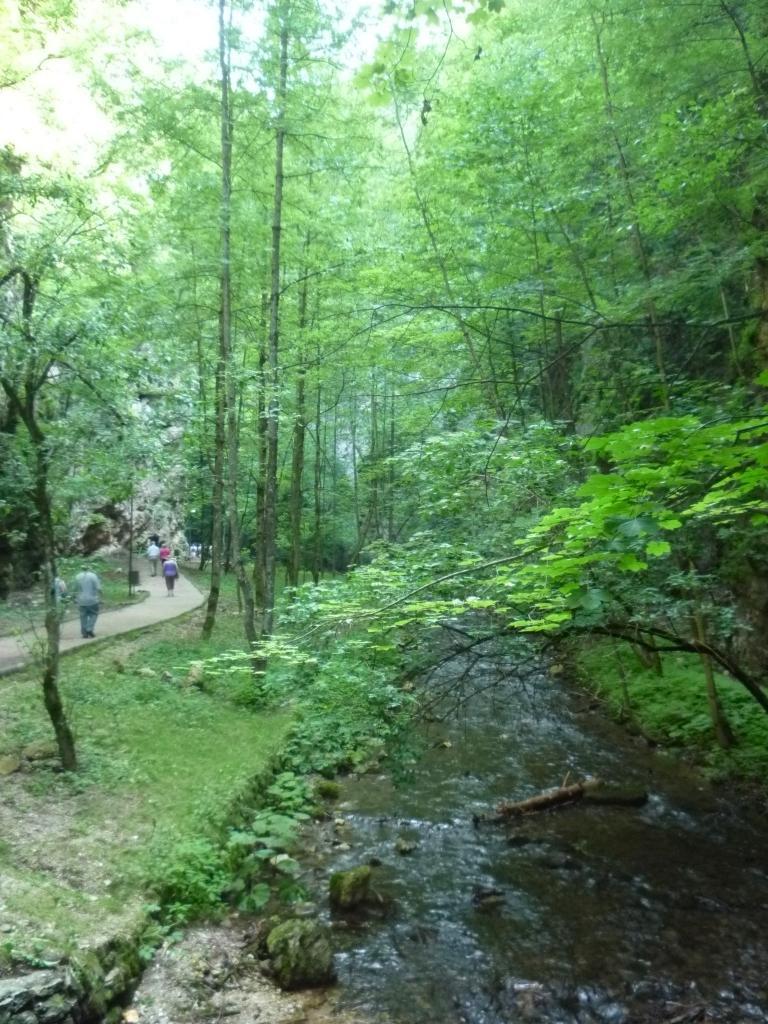In one or two sentences, can you explain what this image depicts? In this picture we can see a wooden object in the water. There are a few bushes visible on the ground. We can see some people on the path. There are a few trees visible in the background. 